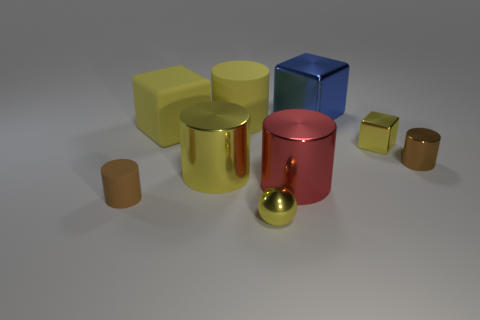How many blocks have the same material as the large red object?
Offer a terse response. 2. There is a small ball; is it the same color as the large metal thing that is left of the small yellow metal ball?
Offer a very short reply. Yes. Are there more yellow metallic things than objects?
Provide a succinct answer. No. The big matte cylinder has what color?
Provide a short and direct response. Yellow. There is a rubber cube behind the small brown rubber thing; is it the same color as the tiny cube?
Give a very brief answer. Yes. There is a big cube that is the same color as the metal ball; what material is it?
Provide a short and direct response. Rubber. What number of tiny metallic balls have the same color as the big matte cylinder?
Your answer should be very brief. 1. There is a large matte object that is left of the big yellow rubber cylinder; does it have the same shape as the big blue object?
Offer a terse response. Yes. Are there fewer small spheres to the right of the red thing than matte blocks in front of the sphere?
Your response must be concise. No. There is a block on the left side of the small yellow sphere; what material is it?
Offer a terse response. Rubber. 